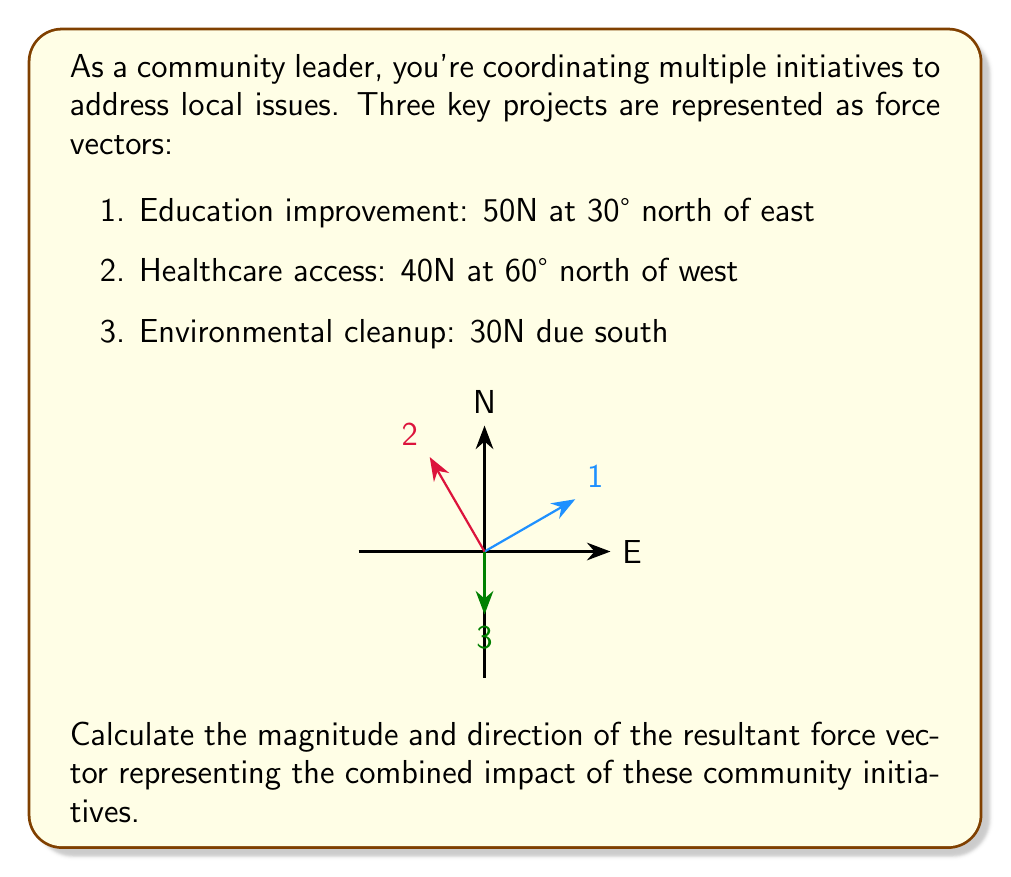Provide a solution to this math problem. To solve this problem, we'll use vector addition and the rectangular (component) method:

1) Convert each vector to its x and y components:

   Education (1): 
   $x_1 = 50 \cos 30° = 43.30$ N
   $y_1 = 50 \sin 30° = 25.00$ N

   Healthcare (2):
   $x_2 = -40 \cos 60° = -20.00$ N
   $y_2 = 40 \sin 60° = 34.64$ N

   Environment (3):
   $x_3 = 0$ N
   $y_3 = -30$ N

2) Sum the x and y components:

   $x_{total} = x_1 + x_2 + x_3 = 43.30 + (-20.00) + 0 = 23.30$ N
   $y_{total} = y_1 + y_2 + y_3 = 25.00 + 34.64 + (-30) = 29.64$ N

3) Calculate the magnitude of the resultant vector:

   $R = \sqrt{x_{total}^2 + y_{total}^2} = \sqrt{23.30^2 + 29.64^2} = 37.71$ N

4) Calculate the direction (angle) of the resultant vector:

   $\theta = \tan^{-1}(\frac{y_{total}}{x_{total}}) = \tan^{-1}(\frac{29.64}{23.30}) = 51.82°$

The angle is measured counterclockwise from the positive x-axis (east).
Answer: 37.71 N at 51.82° north of east 